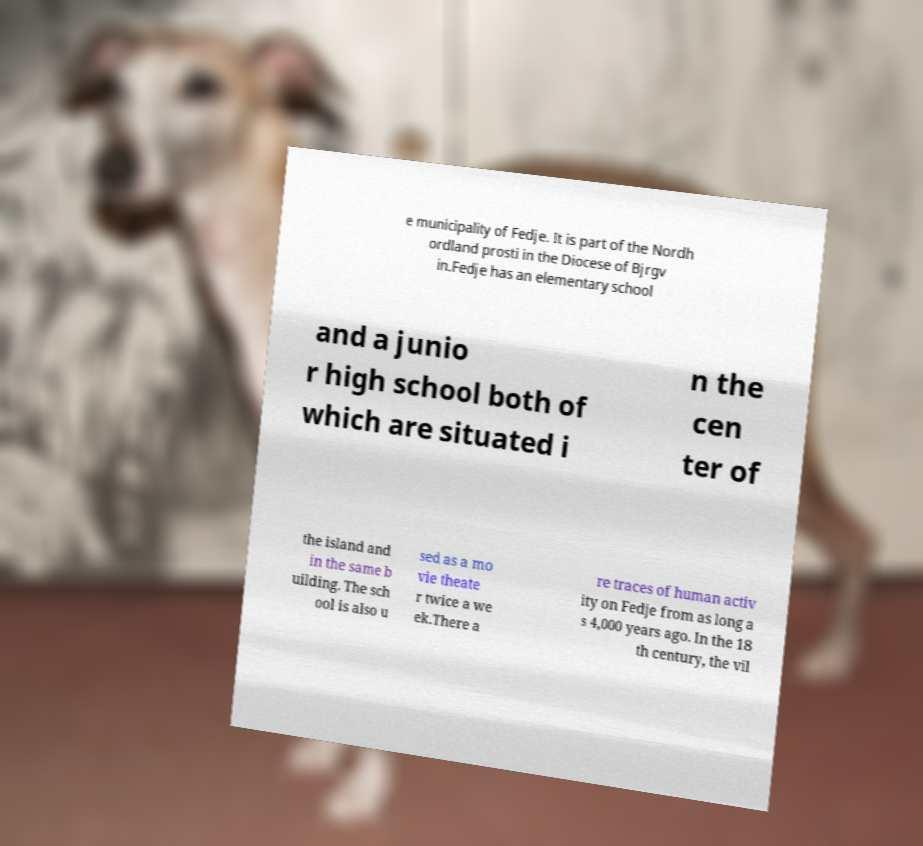Can you read and provide the text displayed in the image?This photo seems to have some interesting text. Can you extract and type it out for me? e municipality of Fedje. It is part of the Nordh ordland prosti in the Diocese of Bjrgv in.Fedje has an elementary school and a junio r high school both of which are situated i n the cen ter of the island and in the same b uilding. The sch ool is also u sed as a mo vie theate r twice a we ek.There a re traces of human activ ity on Fedje from as long a s 4,000 years ago. In the 18 th century, the vil 